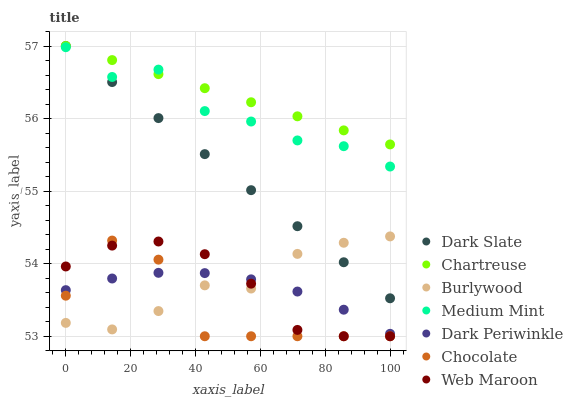Does Chocolate have the minimum area under the curve?
Answer yes or no. Yes. Does Chartreuse have the maximum area under the curve?
Answer yes or no. Yes. Does Burlywood have the minimum area under the curve?
Answer yes or no. No. Does Burlywood have the maximum area under the curve?
Answer yes or no. No. Is Dark Slate the smoothest?
Answer yes or no. Yes. Is Chocolate the roughest?
Answer yes or no. Yes. Is Burlywood the smoothest?
Answer yes or no. No. Is Burlywood the roughest?
Answer yes or no. No. Does Web Maroon have the lowest value?
Answer yes or no. Yes. Does Burlywood have the lowest value?
Answer yes or no. No. Does Chartreuse have the highest value?
Answer yes or no. Yes. Does Burlywood have the highest value?
Answer yes or no. No. Is Web Maroon less than Medium Mint?
Answer yes or no. Yes. Is Dark Slate greater than Web Maroon?
Answer yes or no. Yes. Does Dark Periwinkle intersect Chocolate?
Answer yes or no. Yes. Is Dark Periwinkle less than Chocolate?
Answer yes or no. No. Is Dark Periwinkle greater than Chocolate?
Answer yes or no. No. Does Web Maroon intersect Medium Mint?
Answer yes or no. No. 